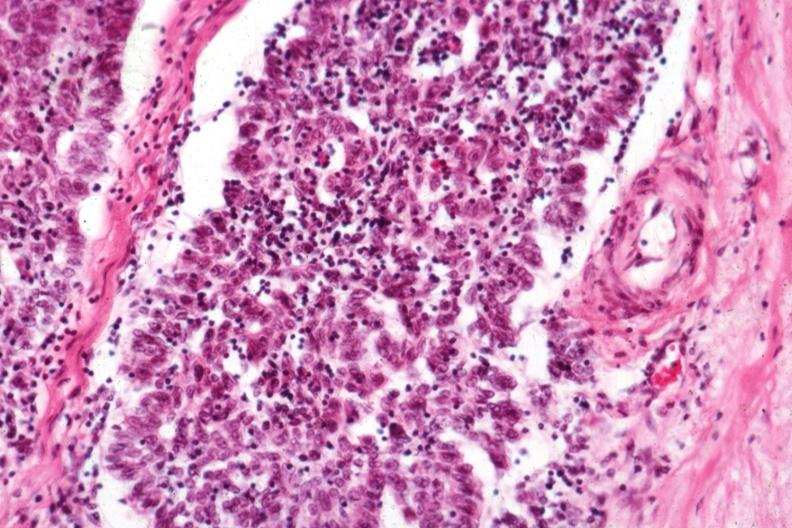s thymoma present?
Answer the question using a single word or phrase. Yes 